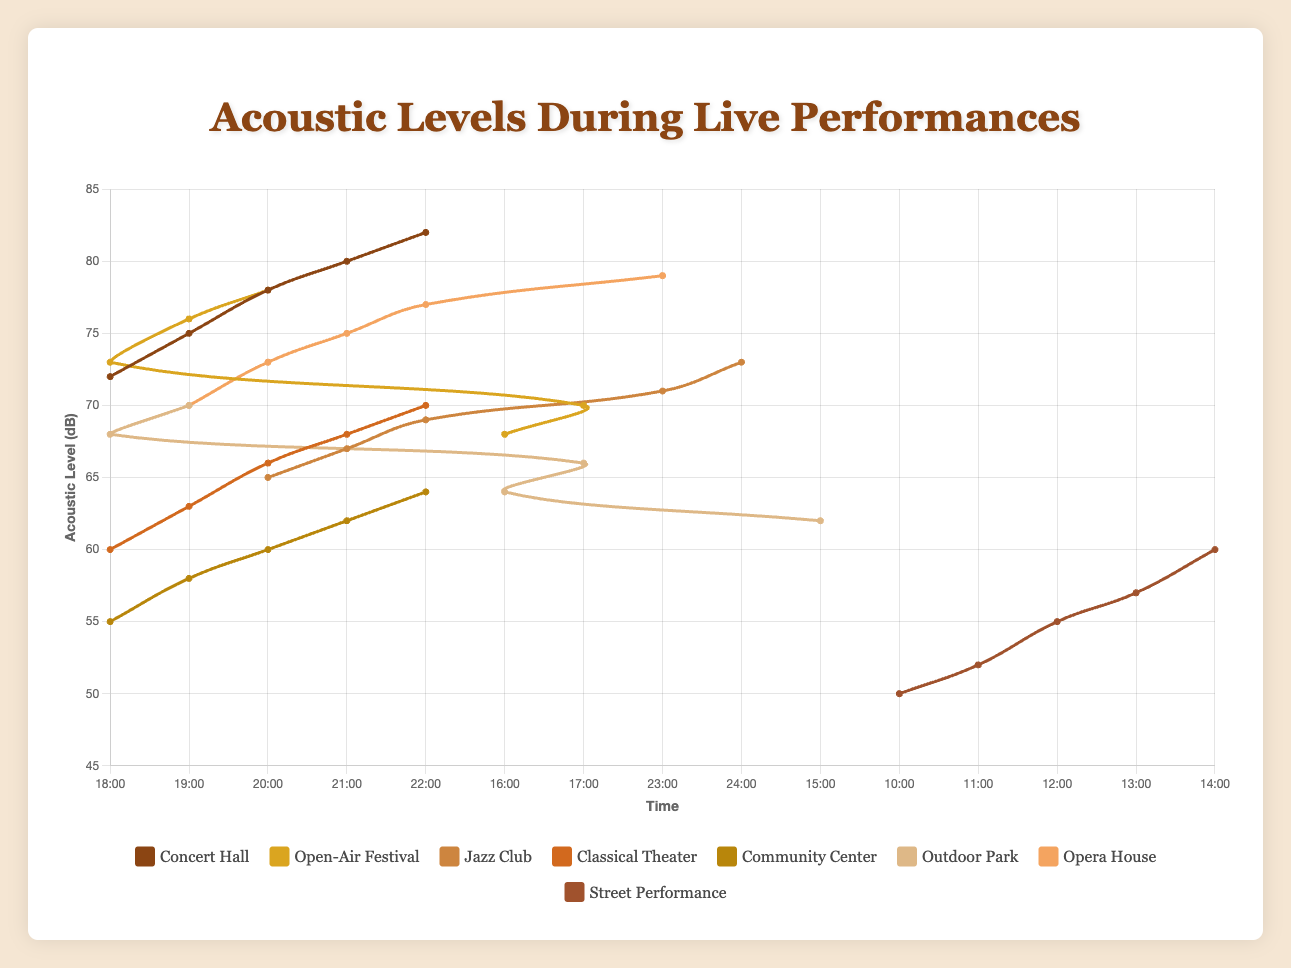Which location has the highest acoustic level recorded in the data? The highest acoustic level is recorded at 82 dB. By reviewing each dataset, the Concert Hall at 22:00 records an acoustic level of 82 dB, which is the highest.
Answer: Concert Hall What is the average acoustic level at the Opera House between 19:00 and 23:00? To get the average, sum the acoustic levels at each hour: (70 + 73 + 75 + 77 + 79) = 374. The number of data points is 5, so the average is 374 / 5 = 74.8 dB.
Answer: 74.8 dB Which location has the lowest initial acoustic level recorded in any observation? The Street Performance at 10:00 records an acoustic level of 50 dB, which is the lowest initial value for any location.
Answer: Street Performance How does the acoustic level at the Open-Air Festival at 18:00 compare to the Jazz Club at the same time? The Open-Air Festival at 18:00 has an acoustic level of 73 dB, while the Jazz Club does not have data for 18:00. So, comparison isn't applicable.
Answer: Not applicable What is the trend in acoustic levels at the Community Center from 18:00 to 22:00? The acoustic levels at the Community Center show a rising trend: 55 at 18:00, 58 at 19:00, 60 at 20:00, 62 at 21:00, and 64 at 22:00.
Answer: Increasing Between 21:00 and 22:00, which location shows the steepest increase in acoustic levels? The Concert Hall goes from 80 dB at 21:00 to 82 dB at 22:00, which is a 2 dB increase. Other locations have either no increase or smaller increases.
Answer: Concert Hall What is the combined acoustic level for the Outdoor Park at 16:00 and the Classical Theater at 20:00? The Outdoor Park at 16:00 has an acoustic level of 64 dB. The Classical Theater at 20:00 has an acoustic level of 66 dB. The combined level is 64 + 66 = 130 dB.
Answer: 130 dB Which two locations have acoustic levels closest to each other at 20:00? At 20:00, the Opera House has 73 dB, and the Open-Air Festival has 73 dB. These two locations have the same acoustic level at 20:00.
Answer: Opera House and Open-Air Festival What is the difference in acoustic levels between 18:00 and 22:00 at the Concert Hall? The acoustic level at the Concert Hall is 72 dB at 18:00 and 82 dB at 22:00. The difference is 82 - 72 = 10 dB.
Answer: 10 dB Which location shows the most gradual increase in acoustic levels over their recorded period? The Community Center increases from 55 dB at 18:00 to 64 dB at 22:00. This increase of 9 dB over 4 hours shows the most gradual increase.
Answer: Community Center 